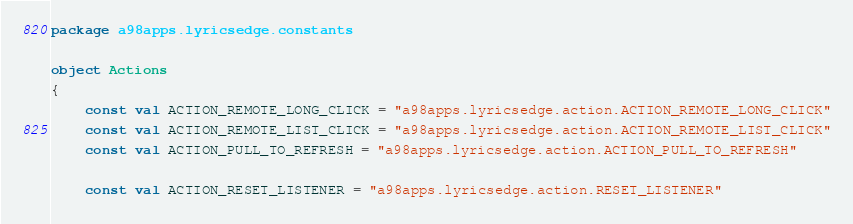Convert code to text. <code><loc_0><loc_0><loc_500><loc_500><_Kotlin_>package a98apps.lyricsedge.constants

object Actions
{
    const val ACTION_REMOTE_LONG_CLICK = "a98apps.lyricsedge.action.ACTION_REMOTE_LONG_CLICK"
    const val ACTION_REMOTE_LIST_CLICK = "a98apps.lyricsedge.action.ACTION_REMOTE_LIST_CLICK"
    const val ACTION_PULL_TO_REFRESH = "a98apps.lyricsedge.action.ACTION_PULL_TO_REFRESH"

    const val ACTION_RESET_LISTENER = "a98apps.lyricsedge.action.RESET_LISTENER"</code> 